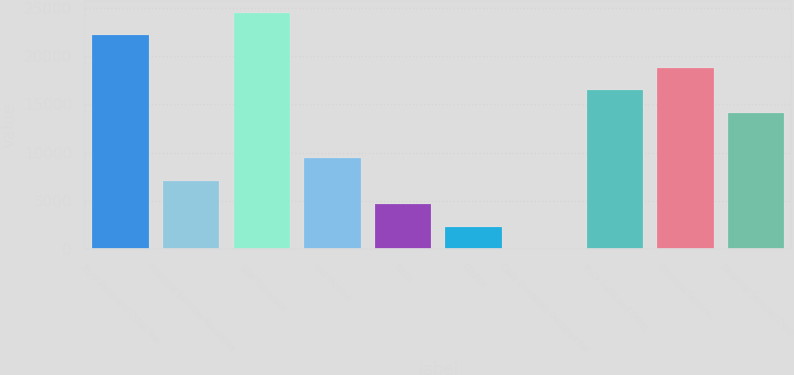Convert chart to OTSL. <chart><loc_0><loc_0><loc_500><loc_500><bar_chart><fcel>Truck Parts and Other Net<fcel>Financial Services Revenues<fcel>Total Revenues<fcel>Net Income<fcel>Basic<fcel>Diluted<fcel>Cash Dividends Declared Per<fcel>Truck Parts and Other<fcel>Financial Services<fcel>Financial Services Debt<nl><fcel>22138.6<fcel>7050.87<fcel>24487.9<fcel>9400.13<fcel>4701.61<fcel>2352.35<fcel>3.09<fcel>16447.9<fcel>18797.2<fcel>14098.6<nl></chart> 